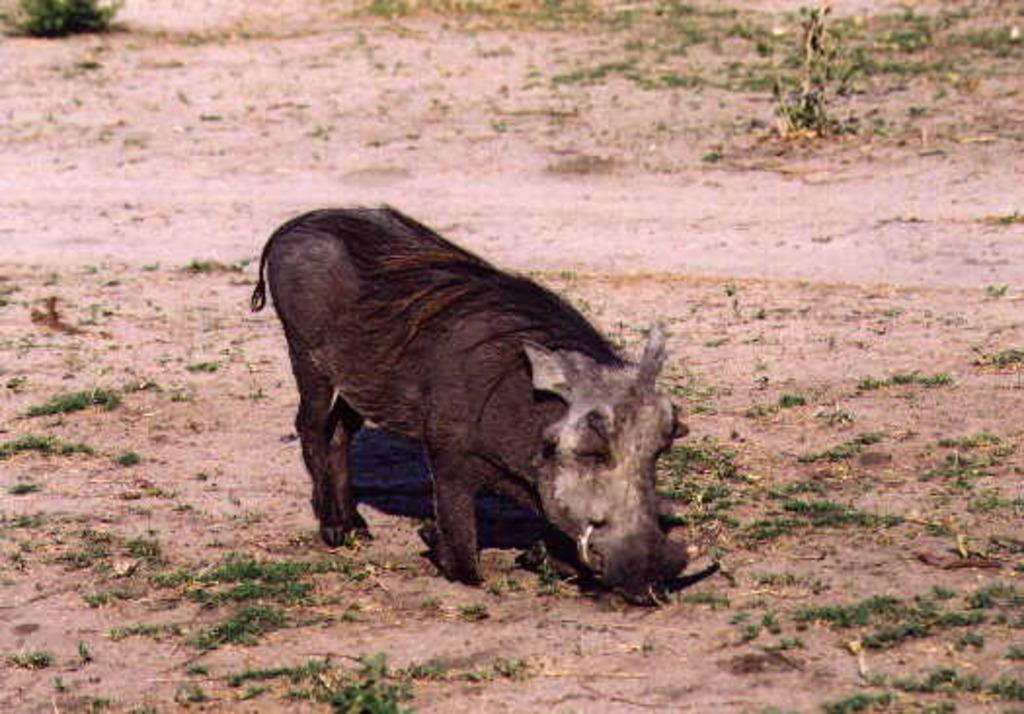What type of living creature is present in the image? There is an animal in the image. What type of book is the animal using to spy on the neighbor's yard in the image? There is no book or neighbor's yard present in the image, and the animal is not shown engaging in any spying activity. 